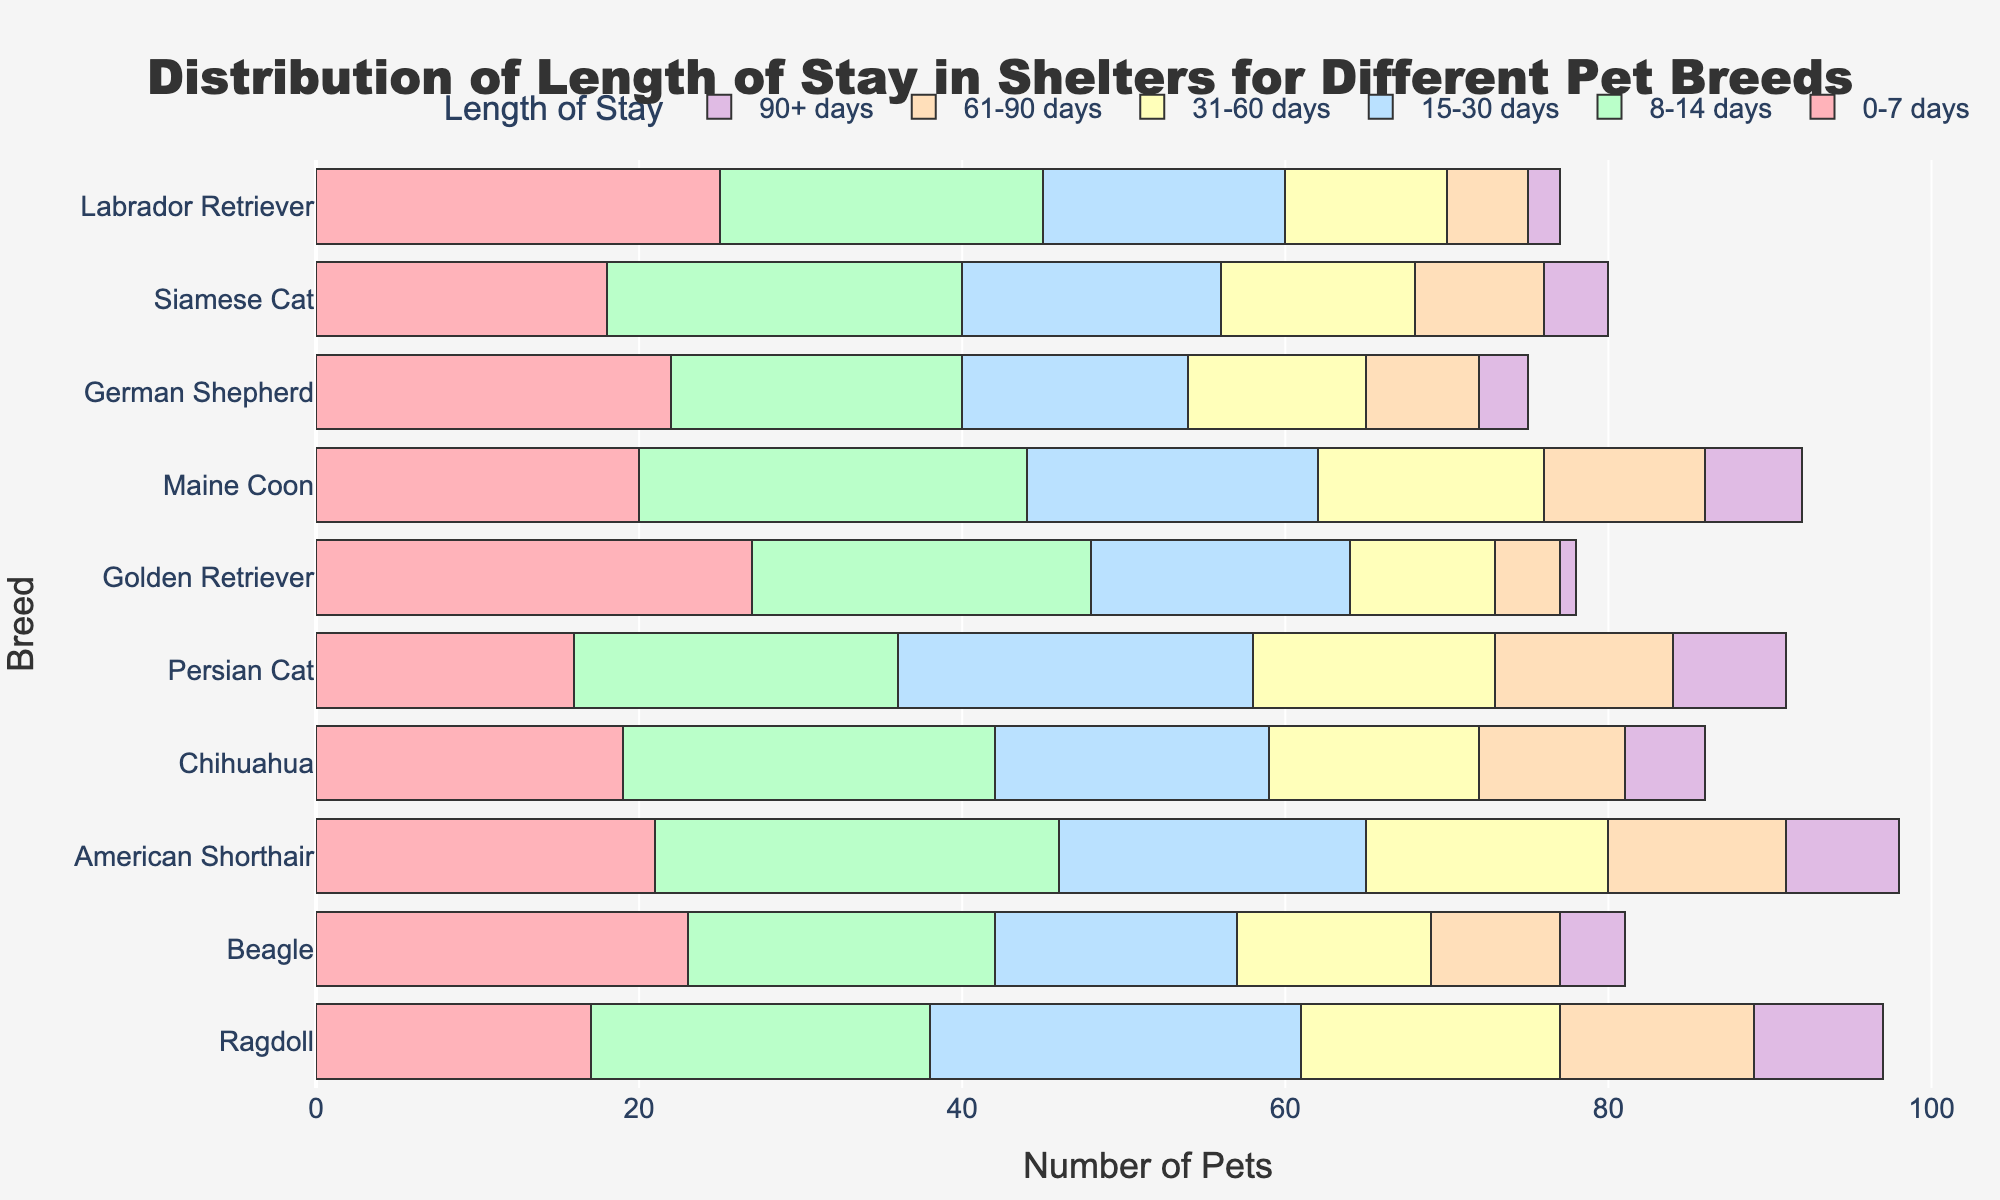What's the title of the figure? Look at the top of the figure where the text describing the main topic is located
Answer: Distribution of Length of Stay in Shelters for Different Pet Breeds Which pet breed has the most pets that stay 0-7 days? Identify the longest bar in the 0-7 days column, and note the corresponding breed name
Answer: Golden Retriever How many pets in total stay more than 90 days for all breeds? Sum the values in the 90+ days column across all breeds
Answer: 48 What is the sum of pets that German Shepherds have for 15-30 days and 31-60 days stays? Locate the values in the 15-30 days and 31-60 days columns for German Shepherd, then add them
Answer: 14 + 11 = 25 Which breed shows the highest number of pets staying 61-90 days? Identify the breed with the longest bar in the 61-90 days column and note the breed name
Answer: Ragdoll Compare the number of pets that stay 8-14 days between German Shepherds and Chihuahuas. Which breed has more? Locate the values in the 8-14 days column for German Shepherd and Chihuahua, then compare them
Answer: Chihuahua (23) Which breed has the least number of pets staying 31-60 days? Identify the shortest bar in the 31-60 days column and note the corresponding breed name
Answer: Golden Retriever How many pets in total stay 0-7 days for both Persian Cats and Siamese Cats combined? Locate the values in the 0-7 days column for Persian Cat and Siamese Cat, then add them
Answer: 16 + 18 = 34 Which breed has a more balanced distribution across all lengths of stay, Labrador Retriever or American Shorthair? Compare the heights of the bars for each length of stay category for both breeds to see which is more evenly distributed
Answer: American Shorthair What's the average number of pets that stay 8-14 days across all breeds? Sum the values in the 8-14 days column across all breeds and divide by the number of breeds (10)
Answer: (20 + 22 + 18 + 24 + 21 + 20 + 23 + 25 + 19 + 21) / 10 = 21.3 